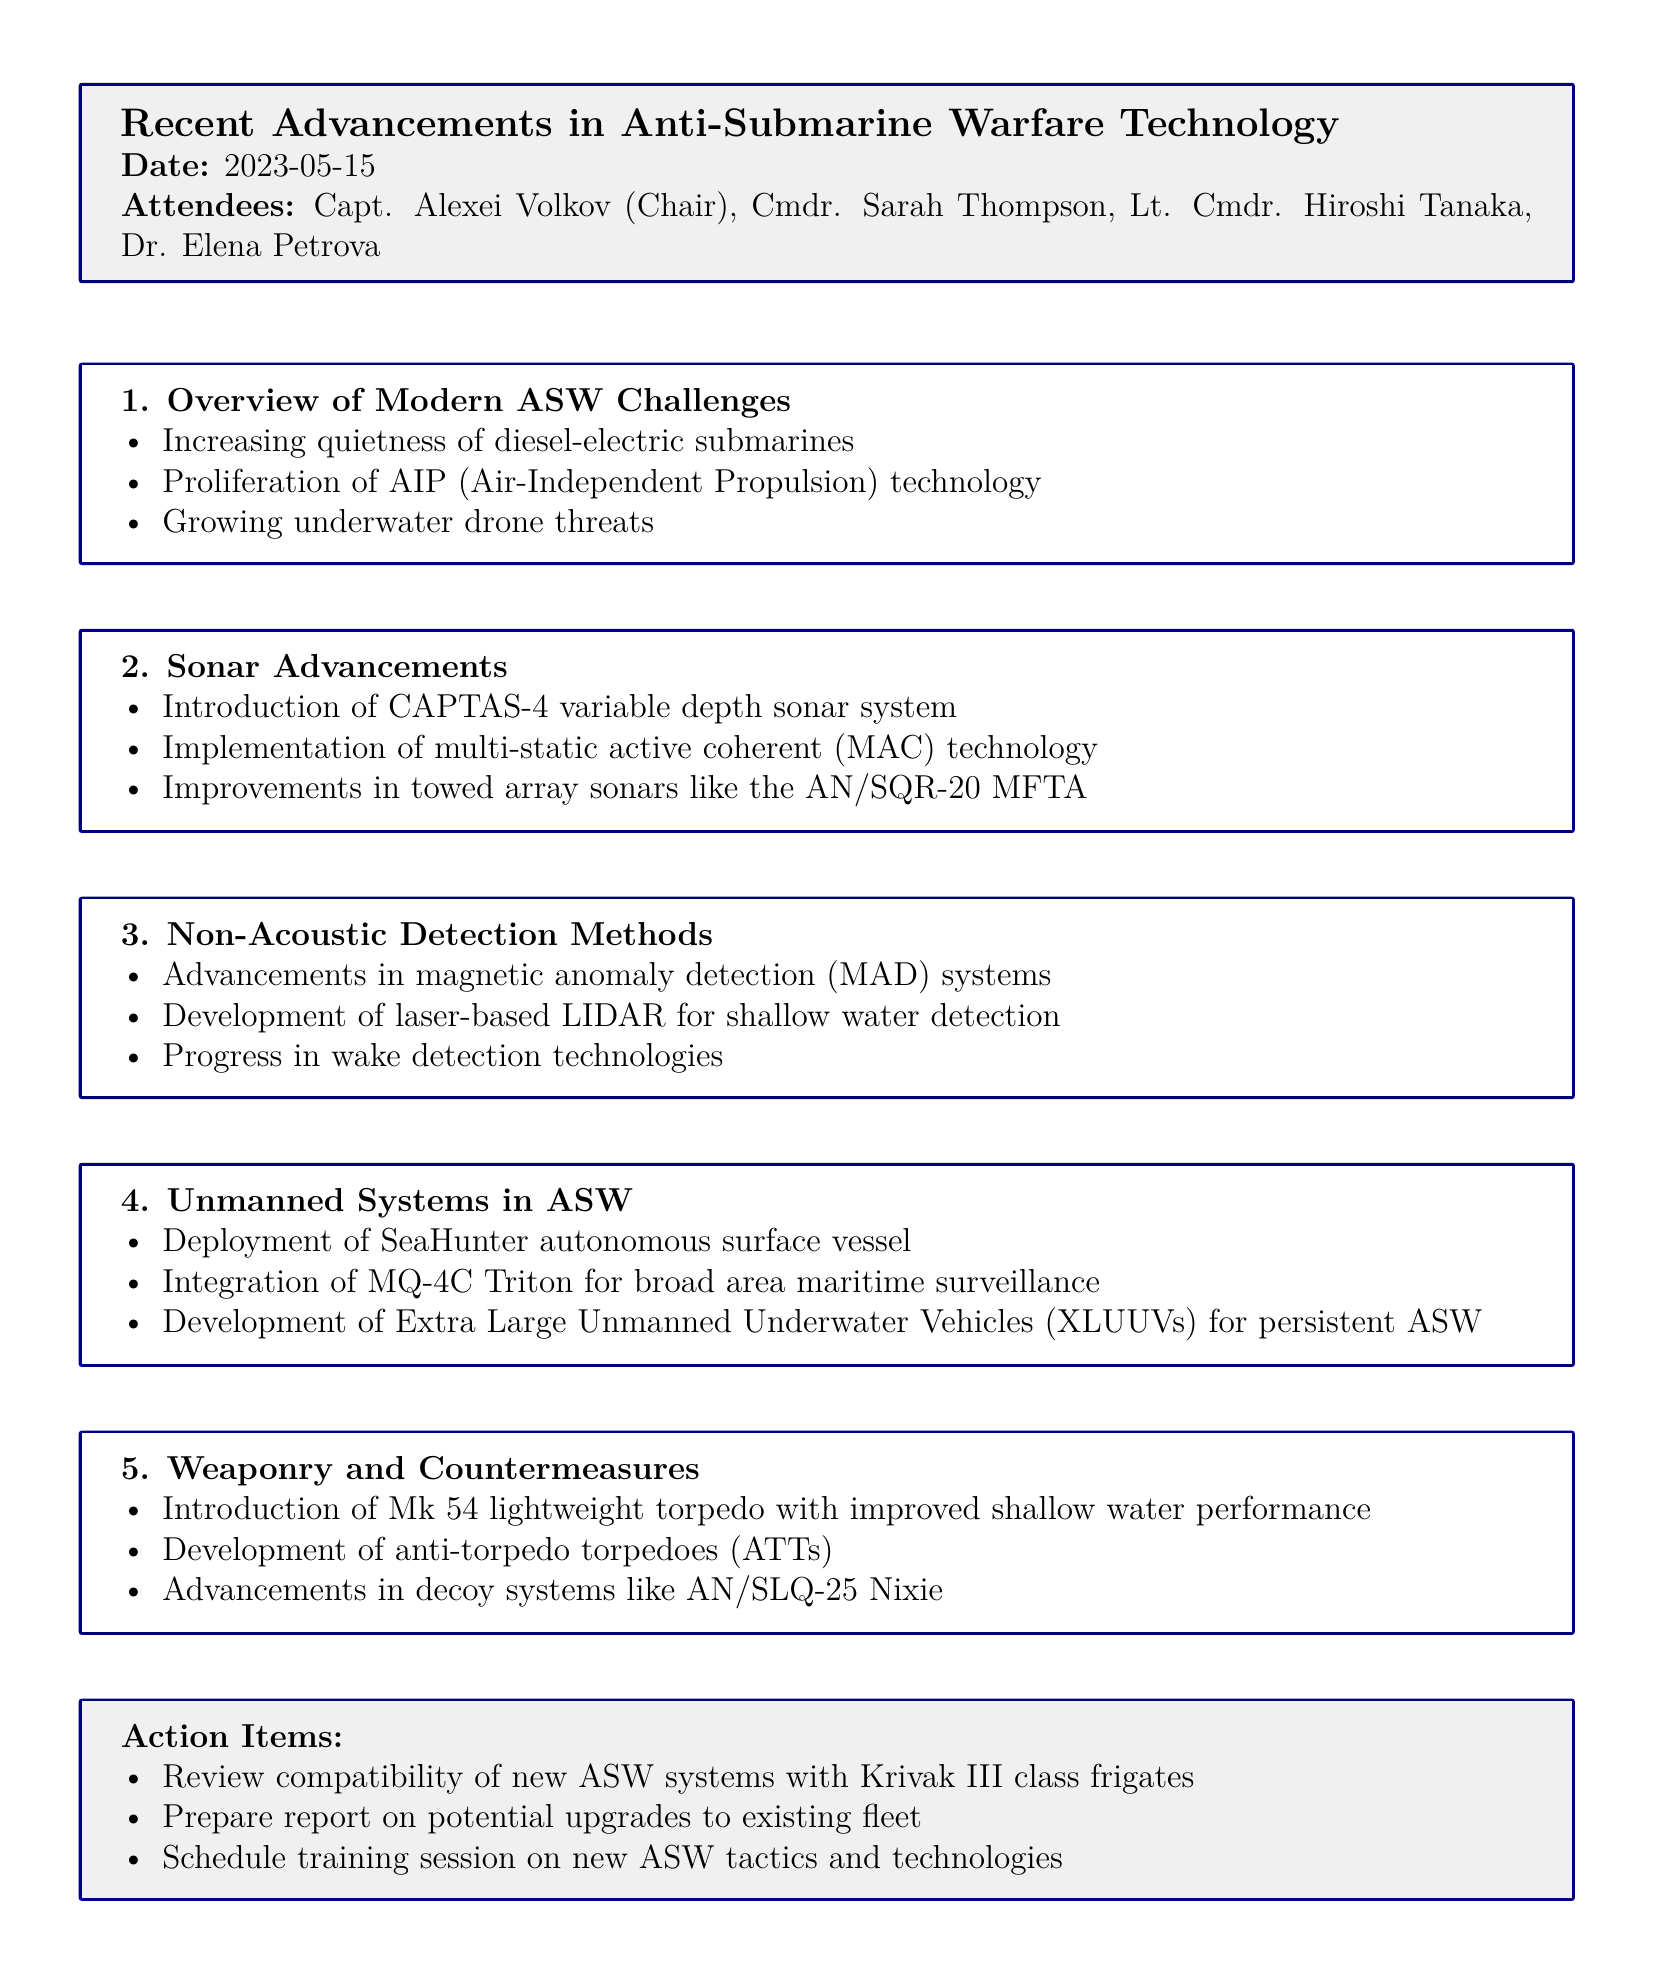What is the meeting title? The meeting title is specified at the top of the document.
Answer: Recent Advancements in Anti-Submarine Warfare Technology Who chaired the meeting? The chairperson of the meeting is listed among the attendees.
Answer: Capt. Alexei Volkov What date was the meeting held? The date is clearly mentioned in the introductory section of the document.
Answer: 2023-05-15 What is the first agenda item? The agenda items are numbered and titled in the document.
Answer: Overview of Modern ASW Challenges Which sonar system was introduced? The document lists advancements in sonar under the second agenda item.
Answer: CAPTAS-4 variable depth sonar system What kind of unmanned system was deployed? The fourth agenda item discusses unmanned systems in ASW.
Answer: SeaHunter autonomous surface vessel What is one of the action items? The action items are collected at the end of the document.
Answer: Review compatibility of new ASW systems with Krivak III class frigates How many attendees were present? The number of attendees can be determined by counting the list provided.
Answer: 4 What technology is mentioned for shallow water detection? This technology is part of the Non-Acoustic Detection Methods section.
Answer: laser-based LIDAR 